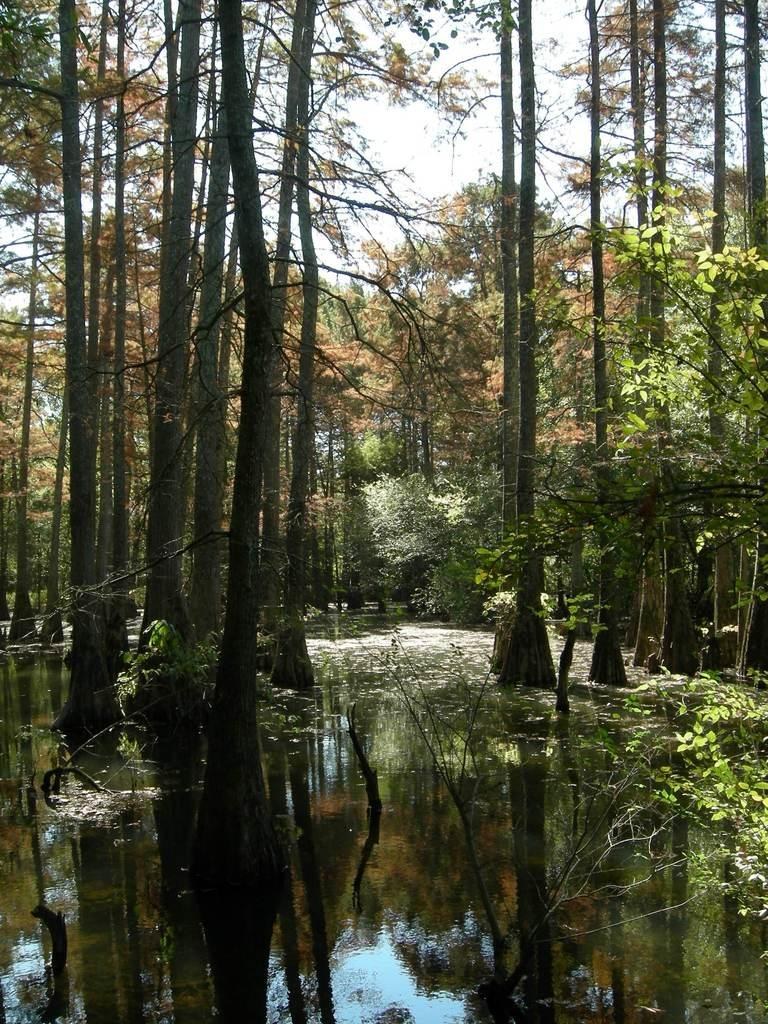What type of vegetation can be seen in the image? There are trees in the image. What natural element is visible besides the trees? There is water visible in the image. What is the color of the sky in the image? The sky appears to be white in color. What type of tool is the carpenter using to burn the trees in the image? There is no carpenter or burning activity present in the image. 